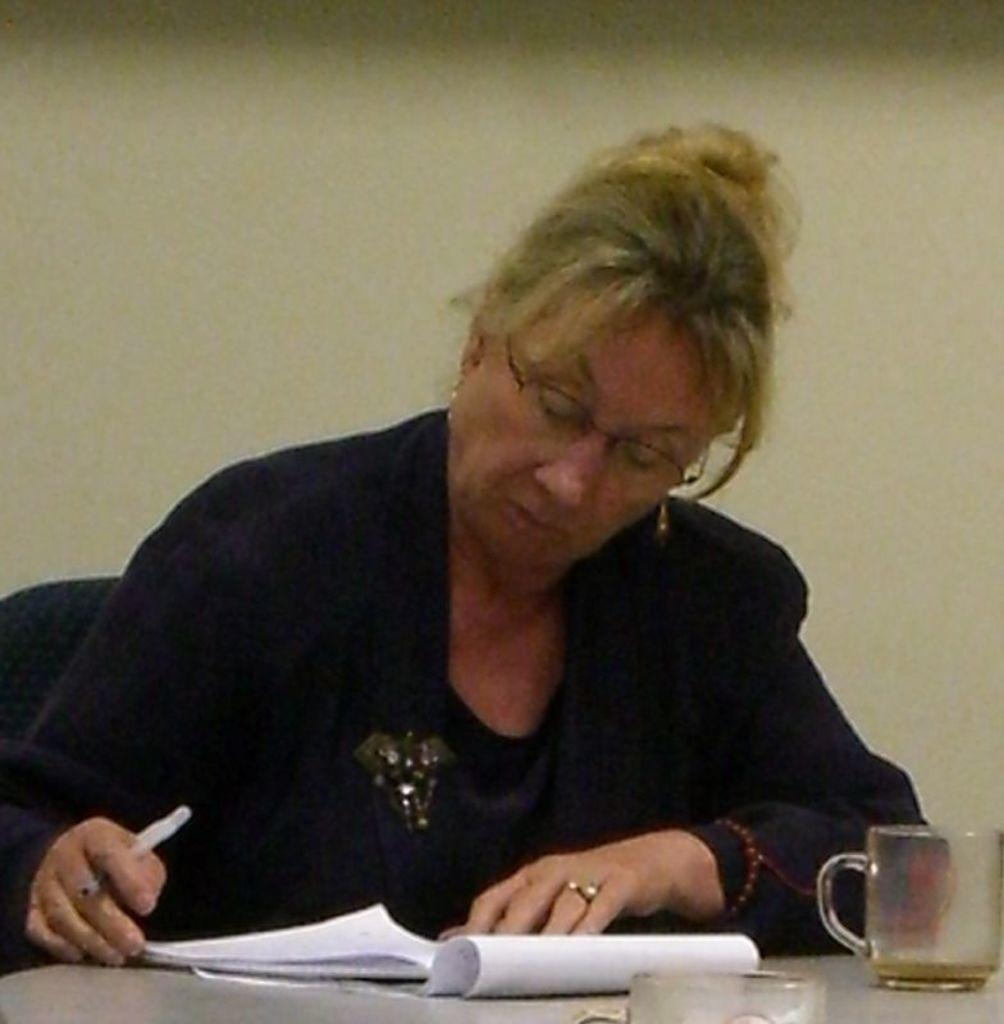What is the woman doing in the image? The woman is sitting on a chair in the image. What is in front of the woman? There is a table in front of the woman. What items can be seen on the table? There is a book and a cup on the table. What is the woman wearing? The woman is wearing a black jacket. What is the woman holding? The woman is holding a pen. Can you see the woman's fang in the image? There is no mention of a fang in the image, and it is not visible. What type of shop is the woman in front of in the image? There is no shop present in the image; it only shows a woman sitting on a chair with a table in front of her. 